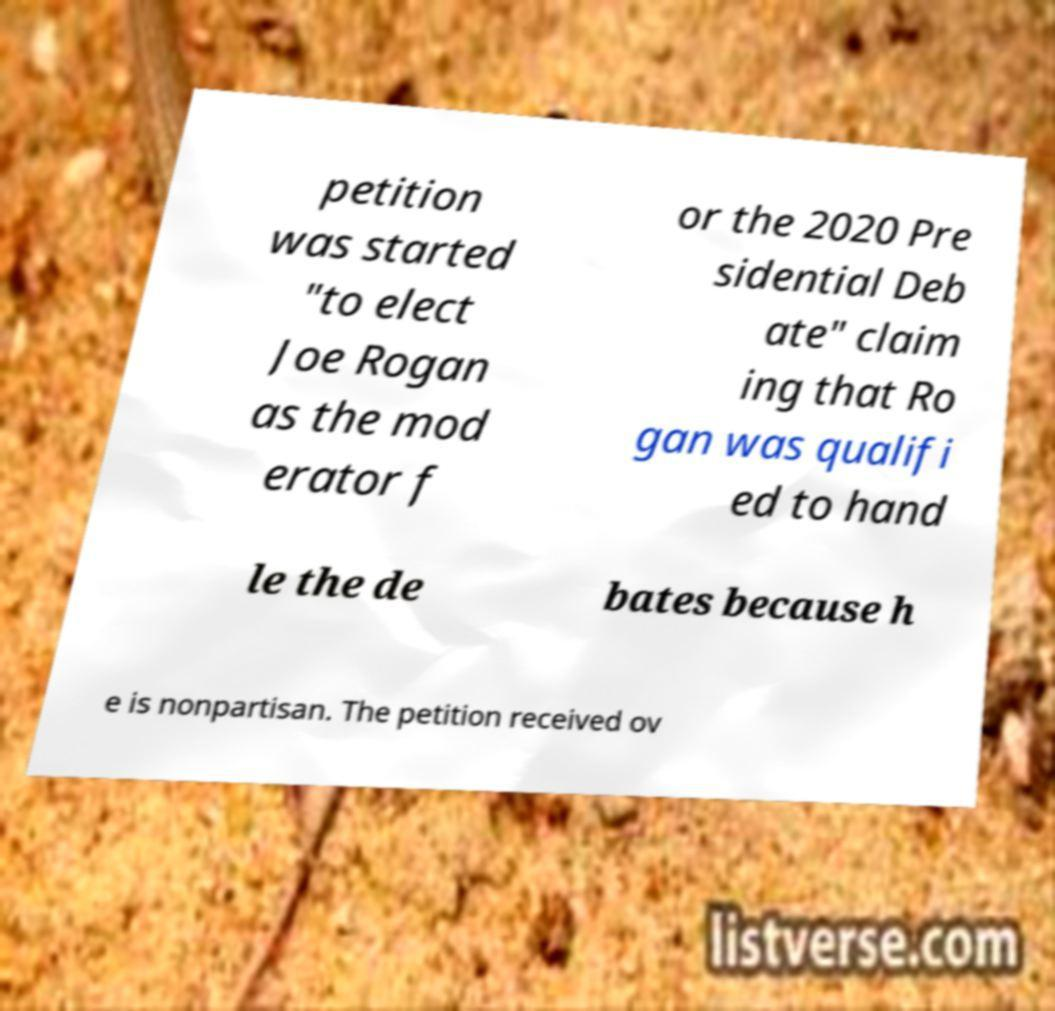Can you read and provide the text displayed in the image?This photo seems to have some interesting text. Can you extract and type it out for me? petition was started "to elect Joe Rogan as the mod erator f or the 2020 Pre sidential Deb ate" claim ing that Ro gan was qualifi ed to hand le the de bates because h e is nonpartisan. The petition received ov 